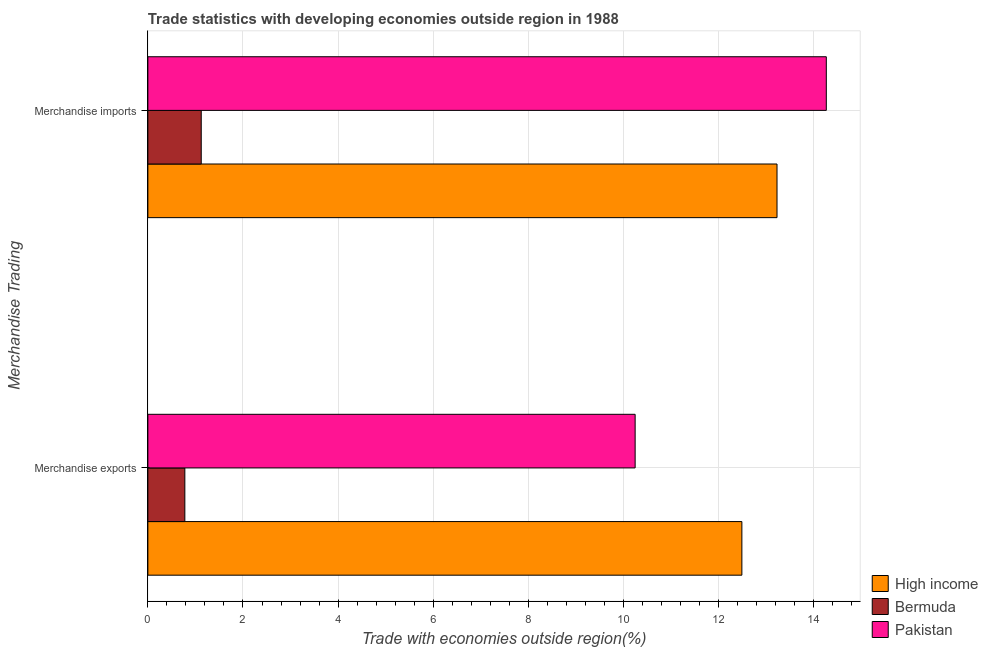How many different coloured bars are there?
Your answer should be very brief. 3. Are the number of bars per tick equal to the number of legend labels?
Make the answer very short. Yes. What is the merchandise imports in Pakistan?
Keep it short and to the point. 14.27. Across all countries, what is the maximum merchandise imports?
Keep it short and to the point. 14.27. Across all countries, what is the minimum merchandise exports?
Ensure brevity in your answer.  0.78. In which country was the merchandise exports minimum?
Offer a terse response. Bermuda. What is the total merchandise exports in the graph?
Ensure brevity in your answer.  23.52. What is the difference between the merchandise exports in High income and that in Pakistan?
Provide a succinct answer. 2.24. What is the difference between the merchandise imports in High income and the merchandise exports in Bermuda?
Give a very brief answer. 12.45. What is the average merchandise imports per country?
Provide a succinct answer. 9.54. What is the difference between the merchandise exports and merchandise imports in Pakistan?
Your answer should be very brief. -4.02. What is the ratio of the merchandise exports in High income to that in Pakistan?
Ensure brevity in your answer.  1.22. What does the 2nd bar from the top in Merchandise exports represents?
Give a very brief answer. Bermuda. Are all the bars in the graph horizontal?
Your answer should be very brief. Yes. How many countries are there in the graph?
Your response must be concise. 3. What is the difference between two consecutive major ticks on the X-axis?
Offer a very short reply. 2. Are the values on the major ticks of X-axis written in scientific E-notation?
Your answer should be very brief. No. Does the graph contain grids?
Your answer should be compact. Yes. Where does the legend appear in the graph?
Your answer should be compact. Bottom right. How are the legend labels stacked?
Provide a short and direct response. Vertical. What is the title of the graph?
Your response must be concise. Trade statistics with developing economies outside region in 1988. What is the label or title of the X-axis?
Offer a terse response. Trade with economies outside region(%). What is the label or title of the Y-axis?
Provide a succinct answer. Merchandise Trading. What is the Trade with economies outside region(%) in High income in Merchandise exports?
Make the answer very short. 12.49. What is the Trade with economies outside region(%) of Bermuda in Merchandise exports?
Make the answer very short. 0.78. What is the Trade with economies outside region(%) of Pakistan in Merchandise exports?
Give a very brief answer. 10.25. What is the Trade with economies outside region(%) in High income in Merchandise imports?
Offer a terse response. 13.23. What is the Trade with economies outside region(%) of Bermuda in Merchandise imports?
Your response must be concise. 1.12. What is the Trade with economies outside region(%) in Pakistan in Merchandise imports?
Keep it short and to the point. 14.27. Across all Merchandise Trading, what is the maximum Trade with economies outside region(%) in High income?
Your answer should be compact. 13.23. Across all Merchandise Trading, what is the maximum Trade with economies outside region(%) of Bermuda?
Provide a succinct answer. 1.12. Across all Merchandise Trading, what is the maximum Trade with economies outside region(%) of Pakistan?
Offer a very short reply. 14.27. Across all Merchandise Trading, what is the minimum Trade with economies outside region(%) of High income?
Offer a very short reply. 12.49. Across all Merchandise Trading, what is the minimum Trade with economies outside region(%) in Bermuda?
Your answer should be compact. 0.78. Across all Merchandise Trading, what is the minimum Trade with economies outside region(%) in Pakistan?
Your answer should be very brief. 10.25. What is the total Trade with economies outside region(%) of High income in the graph?
Ensure brevity in your answer.  25.72. What is the total Trade with economies outside region(%) of Bermuda in the graph?
Keep it short and to the point. 1.9. What is the total Trade with economies outside region(%) of Pakistan in the graph?
Offer a terse response. 24.51. What is the difference between the Trade with economies outside region(%) of High income in Merchandise exports and that in Merchandise imports?
Make the answer very short. -0.74. What is the difference between the Trade with economies outside region(%) in Bermuda in Merchandise exports and that in Merchandise imports?
Offer a very short reply. -0.34. What is the difference between the Trade with economies outside region(%) of Pakistan in Merchandise exports and that in Merchandise imports?
Provide a succinct answer. -4.02. What is the difference between the Trade with economies outside region(%) in High income in Merchandise exports and the Trade with economies outside region(%) in Bermuda in Merchandise imports?
Offer a very short reply. 11.37. What is the difference between the Trade with economies outside region(%) in High income in Merchandise exports and the Trade with economies outside region(%) in Pakistan in Merchandise imports?
Ensure brevity in your answer.  -1.78. What is the difference between the Trade with economies outside region(%) in Bermuda in Merchandise exports and the Trade with economies outside region(%) in Pakistan in Merchandise imports?
Your answer should be very brief. -13.49. What is the average Trade with economies outside region(%) in High income per Merchandise Trading?
Provide a succinct answer. 12.86. What is the average Trade with economies outside region(%) of Bermuda per Merchandise Trading?
Give a very brief answer. 0.95. What is the average Trade with economies outside region(%) of Pakistan per Merchandise Trading?
Give a very brief answer. 12.26. What is the difference between the Trade with economies outside region(%) in High income and Trade with economies outside region(%) in Bermuda in Merchandise exports?
Offer a very short reply. 11.71. What is the difference between the Trade with economies outside region(%) of High income and Trade with economies outside region(%) of Pakistan in Merchandise exports?
Your answer should be very brief. 2.24. What is the difference between the Trade with economies outside region(%) in Bermuda and Trade with economies outside region(%) in Pakistan in Merchandise exports?
Ensure brevity in your answer.  -9.47. What is the difference between the Trade with economies outside region(%) in High income and Trade with economies outside region(%) in Bermuda in Merchandise imports?
Offer a very short reply. 12.11. What is the difference between the Trade with economies outside region(%) in High income and Trade with economies outside region(%) in Pakistan in Merchandise imports?
Provide a short and direct response. -1.04. What is the difference between the Trade with economies outside region(%) of Bermuda and Trade with economies outside region(%) of Pakistan in Merchandise imports?
Give a very brief answer. -13.14. What is the ratio of the Trade with economies outside region(%) of High income in Merchandise exports to that in Merchandise imports?
Your response must be concise. 0.94. What is the ratio of the Trade with economies outside region(%) in Bermuda in Merchandise exports to that in Merchandise imports?
Provide a succinct answer. 0.69. What is the ratio of the Trade with economies outside region(%) of Pakistan in Merchandise exports to that in Merchandise imports?
Offer a very short reply. 0.72. What is the difference between the highest and the second highest Trade with economies outside region(%) of High income?
Your response must be concise. 0.74. What is the difference between the highest and the second highest Trade with economies outside region(%) of Bermuda?
Provide a succinct answer. 0.34. What is the difference between the highest and the second highest Trade with economies outside region(%) in Pakistan?
Give a very brief answer. 4.02. What is the difference between the highest and the lowest Trade with economies outside region(%) in High income?
Make the answer very short. 0.74. What is the difference between the highest and the lowest Trade with economies outside region(%) in Bermuda?
Offer a very short reply. 0.34. What is the difference between the highest and the lowest Trade with economies outside region(%) in Pakistan?
Offer a very short reply. 4.02. 